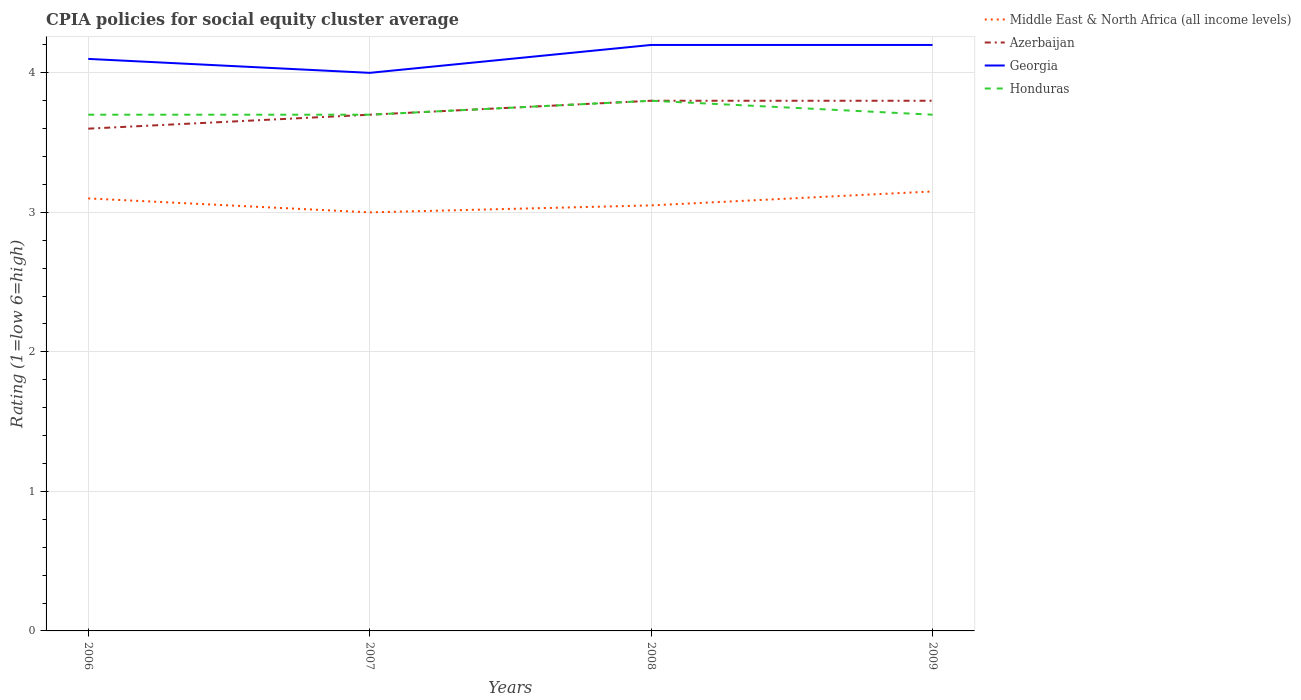Does the line corresponding to Honduras intersect with the line corresponding to Georgia?
Provide a short and direct response. No. Is the number of lines equal to the number of legend labels?
Keep it short and to the point. Yes. Across all years, what is the maximum CPIA rating in Azerbaijan?
Your answer should be compact. 3.6. What is the total CPIA rating in Middle East & North Africa (all income levels) in the graph?
Provide a short and direct response. -0.05. What is the difference between the highest and the second highest CPIA rating in Middle East & North Africa (all income levels)?
Offer a very short reply. 0.15. Is the CPIA rating in Azerbaijan strictly greater than the CPIA rating in Georgia over the years?
Keep it short and to the point. Yes. How many years are there in the graph?
Your answer should be compact. 4. What is the difference between two consecutive major ticks on the Y-axis?
Ensure brevity in your answer.  1. Are the values on the major ticks of Y-axis written in scientific E-notation?
Your answer should be very brief. No. Does the graph contain grids?
Make the answer very short. Yes. Where does the legend appear in the graph?
Make the answer very short. Top right. How many legend labels are there?
Your answer should be compact. 4. How are the legend labels stacked?
Give a very brief answer. Vertical. What is the title of the graph?
Give a very brief answer. CPIA policies for social equity cluster average. What is the Rating (1=low 6=high) in Azerbaijan in 2006?
Ensure brevity in your answer.  3.6. What is the Rating (1=low 6=high) in Georgia in 2007?
Give a very brief answer. 4. What is the Rating (1=low 6=high) in Honduras in 2007?
Your response must be concise. 3.7. What is the Rating (1=low 6=high) of Middle East & North Africa (all income levels) in 2008?
Provide a short and direct response. 3.05. What is the Rating (1=low 6=high) of Azerbaijan in 2008?
Make the answer very short. 3.8. What is the Rating (1=low 6=high) in Middle East & North Africa (all income levels) in 2009?
Your answer should be very brief. 3.15. What is the Rating (1=low 6=high) in Azerbaijan in 2009?
Offer a terse response. 3.8. What is the Rating (1=low 6=high) in Georgia in 2009?
Make the answer very short. 4.2. Across all years, what is the maximum Rating (1=low 6=high) of Middle East & North Africa (all income levels)?
Give a very brief answer. 3.15. Across all years, what is the maximum Rating (1=low 6=high) in Georgia?
Offer a very short reply. 4.2. Across all years, what is the minimum Rating (1=low 6=high) of Middle East & North Africa (all income levels)?
Provide a succinct answer. 3. Across all years, what is the minimum Rating (1=low 6=high) of Azerbaijan?
Offer a terse response. 3.6. Across all years, what is the minimum Rating (1=low 6=high) of Georgia?
Provide a succinct answer. 4. What is the total Rating (1=low 6=high) in Middle East & North Africa (all income levels) in the graph?
Make the answer very short. 12.3. What is the total Rating (1=low 6=high) in Honduras in the graph?
Provide a short and direct response. 14.9. What is the difference between the Rating (1=low 6=high) of Middle East & North Africa (all income levels) in 2006 and that in 2007?
Provide a succinct answer. 0.1. What is the difference between the Rating (1=low 6=high) in Georgia in 2006 and that in 2007?
Give a very brief answer. 0.1. What is the difference between the Rating (1=low 6=high) in Georgia in 2006 and that in 2008?
Your answer should be compact. -0.1. What is the difference between the Rating (1=low 6=high) of Azerbaijan in 2006 and that in 2009?
Give a very brief answer. -0.2. What is the difference between the Rating (1=low 6=high) in Georgia in 2006 and that in 2009?
Keep it short and to the point. -0.1. What is the difference between the Rating (1=low 6=high) of Middle East & North Africa (all income levels) in 2007 and that in 2008?
Provide a succinct answer. -0.05. What is the difference between the Rating (1=low 6=high) of Georgia in 2007 and that in 2008?
Keep it short and to the point. -0.2. What is the difference between the Rating (1=low 6=high) of Honduras in 2007 and that in 2008?
Offer a terse response. -0.1. What is the difference between the Rating (1=low 6=high) of Middle East & North Africa (all income levels) in 2007 and that in 2009?
Provide a short and direct response. -0.15. What is the difference between the Rating (1=low 6=high) in Azerbaijan in 2007 and that in 2009?
Your answer should be compact. -0.1. What is the difference between the Rating (1=low 6=high) in Middle East & North Africa (all income levels) in 2008 and that in 2009?
Offer a very short reply. -0.1. What is the difference between the Rating (1=low 6=high) of Georgia in 2008 and that in 2009?
Provide a short and direct response. 0. What is the difference between the Rating (1=low 6=high) of Middle East & North Africa (all income levels) in 2006 and the Rating (1=low 6=high) of Azerbaijan in 2007?
Give a very brief answer. -0.6. What is the difference between the Rating (1=low 6=high) in Azerbaijan in 2006 and the Rating (1=low 6=high) in Honduras in 2007?
Make the answer very short. -0.1. What is the difference between the Rating (1=low 6=high) in Georgia in 2006 and the Rating (1=low 6=high) in Honduras in 2007?
Provide a succinct answer. 0.4. What is the difference between the Rating (1=low 6=high) in Middle East & North Africa (all income levels) in 2006 and the Rating (1=low 6=high) in Georgia in 2008?
Offer a terse response. -1.1. What is the difference between the Rating (1=low 6=high) in Middle East & North Africa (all income levels) in 2006 and the Rating (1=low 6=high) in Honduras in 2008?
Provide a succinct answer. -0.7. What is the difference between the Rating (1=low 6=high) in Azerbaijan in 2006 and the Rating (1=low 6=high) in Georgia in 2008?
Provide a succinct answer. -0.6. What is the difference between the Rating (1=low 6=high) of Georgia in 2006 and the Rating (1=low 6=high) of Honduras in 2008?
Provide a succinct answer. 0.3. What is the difference between the Rating (1=low 6=high) in Middle East & North Africa (all income levels) in 2006 and the Rating (1=low 6=high) in Azerbaijan in 2009?
Ensure brevity in your answer.  -0.7. What is the difference between the Rating (1=low 6=high) in Middle East & North Africa (all income levels) in 2006 and the Rating (1=low 6=high) in Honduras in 2009?
Your answer should be compact. -0.6. What is the difference between the Rating (1=low 6=high) in Azerbaijan in 2006 and the Rating (1=low 6=high) in Georgia in 2009?
Your response must be concise. -0.6. What is the difference between the Rating (1=low 6=high) of Middle East & North Africa (all income levels) in 2007 and the Rating (1=low 6=high) of Georgia in 2008?
Your answer should be very brief. -1.2. What is the difference between the Rating (1=low 6=high) in Middle East & North Africa (all income levels) in 2007 and the Rating (1=low 6=high) in Honduras in 2008?
Provide a succinct answer. -0.8. What is the difference between the Rating (1=low 6=high) of Azerbaijan in 2007 and the Rating (1=low 6=high) of Honduras in 2008?
Provide a short and direct response. -0.1. What is the difference between the Rating (1=low 6=high) in Georgia in 2007 and the Rating (1=low 6=high) in Honduras in 2008?
Provide a succinct answer. 0.2. What is the difference between the Rating (1=low 6=high) of Middle East & North Africa (all income levels) in 2007 and the Rating (1=low 6=high) of Georgia in 2009?
Your response must be concise. -1.2. What is the difference between the Rating (1=low 6=high) in Middle East & North Africa (all income levels) in 2008 and the Rating (1=low 6=high) in Azerbaijan in 2009?
Provide a short and direct response. -0.75. What is the difference between the Rating (1=low 6=high) of Middle East & North Africa (all income levels) in 2008 and the Rating (1=low 6=high) of Georgia in 2009?
Keep it short and to the point. -1.15. What is the difference between the Rating (1=low 6=high) of Middle East & North Africa (all income levels) in 2008 and the Rating (1=low 6=high) of Honduras in 2009?
Offer a terse response. -0.65. What is the difference between the Rating (1=low 6=high) of Georgia in 2008 and the Rating (1=low 6=high) of Honduras in 2009?
Make the answer very short. 0.5. What is the average Rating (1=low 6=high) of Middle East & North Africa (all income levels) per year?
Give a very brief answer. 3.08. What is the average Rating (1=low 6=high) of Azerbaijan per year?
Your response must be concise. 3.73. What is the average Rating (1=low 6=high) in Georgia per year?
Give a very brief answer. 4.12. What is the average Rating (1=low 6=high) in Honduras per year?
Provide a succinct answer. 3.73. In the year 2006, what is the difference between the Rating (1=low 6=high) of Middle East & North Africa (all income levels) and Rating (1=low 6=high) of Azerbaijan?
Offer a very short reply. -0.5. In the year 2006, what is the difference between the Rating (1=low 6=high) of Azerbaijan and Rating (1=low 6=high) of Georgia?
Make the answer very short. -0.5. In the year 2006, what is the difference between the Rating (1=low 6=high) in Azerbaijan and Rating (1=low 6=high) in Honduras?
Keep it short and to the point. -0.1. In the year 2007, what is the difference between the Rating (1=low 6=high) of Middle East & North Africa (all income levels) and Rating (1=low 6=high) of Azerbaijan?
Give a very brief answer. -0.7. In the year 2007, what is the difference between the Rating (1=low 6=high) in Middle East & North Africa (all income levels) and Rating (1=low 6=high) in Georgia?
Your answer should be compact. -1. In the year 2007, what is the difference between the Rating (1=low 6=high) in Azerbaijan and Rating (1=low 6=high) in Honduras?
Offer a very short reply. 0. In the year 2008, what is the difference between the Rating (1=low 6=high) in Middle East & North Africa (all income levels) and Rating (1=low 6=high) in Azerbaijan?
Offer a terse response. -0.75. In the year 2008, what is the difference between the Rating (1=low 6=high) in Middle East & North Africa (all income levels) and Rating (1=low 6=high) in Georgia?
Your response must be concise. -1.15. In the year 2008, what is the difference between the Rating (1=low 6=high) in Middle East & North Africa (all income levels) and Rating (1=low 6=high) in Honduras?
Offer a very short reply. -0.75. In the year 2008, what is the difference between the Rating (1=low 6=high) of Azerbaijan and Rating (1=low 6=high) of Georgia?
Give a very brief answer. -0.4. In the year 2009, what is the difference between the Rating (1=low 6=high) of Middle East & North Africa (all income levels) and Rating (1=low 6=high) of Azerbaijan?
Your response must be concise. -0.65. In the year 2009, what is the difference between the Rating (1=low 6=high) of Middle East & North Africa (all income levels) and Rating (1=low 6=high) of Georgia?
Make the answer very short. -1.05. In the year 2009, what is the difference between the Rating (1=low 6=high) of Middle East & North Africa (all income levels) and Rating (1=low 6=high) of Honduras?
Provide a succinct answer. -0.55. In the year 2009, what is the difference between the Rating (1=low 6=high) in Azerbaijan and Rating (1=low 6=high) in Georgia?
Your answer should be very brief. -0.4. In the year 2009, what is the difference between the Rating (1=low 6=high) of Azerbaijan and Rating (1=low 6=high) of Honduras?
Offer a very short reply. 0.1. In the year 2009, what is the difference between the Rating (1=low 6=high) of Georgia and Rating (1=low 6=high) of Honduras?
Keep it short and to the point. 0.5. What is the ratio of the Rating (1=low 6=high) of Azerbaijan in 2006 to that in 2007?
Your response must be concise. 0.97. What is the ratio of the Rating (1=low 6=high) in Honduras in 2006 to that in 2007?
Provide a short and direct response. 1. What is the ratio of the Rating (1=low 6=high) in Middle East & North Africa (all income levels) in 2006 to that in 2008?
Your response must be concise. 1.02. What is the ratio of the Rating (1=low 6=high) of Azerbaijan in 2006 to that in 2008?
Offer a terse response. 0.95. What is the ratio of the Rating (1=low 6=high) in Georgia in 2006 to that in 2008?
Your response must be concise. 0.98. What is the ratio of the Rating (1=low 6=high) in Honduras in 2006 to that in 2008?
Make the answer very short. 0.97. What is the ratio of the Rating (1=low 6=high) in Middle East & North Africa (all income levels) in 2006 to that in 2009?
Your answer should be very brief. 0.98. What is the ratio of the Rating (1=low 6=high) of Azerbaijan in 2006 to that in 2009?
Provide a short and direct response. 0.95. What is the ratio of the Rating (1=low 6=high) of Georgia in 2006 to that in 2009?
Ensure brevity in your answer.  0.98. What is the ratio of the Rating (1=low 6=high) of Middle East & North Africa (all income levels) in 2007 to that in 2008?
Give a very brief answer. 0.98. What is the ratio of the Rating (1=low 6=high) of Azerbaijan in 2007 to that in 2008?
Ensure brevity in your answer.  0.97. What is the ratio of the Rating (1=low 6=high) in Georgia in 2007 to that in 2008?
Provide a short and direct response. 0.95. What is the ratio of the Rating (1=low 6=high) of Honduras in 2007 to that in 2008?
Offer a terse response. 0.97. What is the ratio of the Rating (1=low 6=high) of Middle East & North Africa (all income levels) in 2007 to that in 2009?
Ensure brevity in your answer.  0.95. What is the ratio of the Rating (1=low 6=high) of Azerbaijan in 2007 to that in 2009?
Your answer should be compact. 0.97. What is the ratio of the Rating (1=low 6=high) of Georgia in 2007 to that in 2009?
Offer a terse response. 0.95. What is the ratio of the Rating (1=low 6=high) in Middle East & North Africa (all income levels) in 2008 to that in 2009?
Your answer should be very brief. 0.97. What is the ratio of the Rating (1=low 6=high) of Azerbaijan in 2008 to that in 2009?
Your answer should be very brief. 1. What is the difference between the highest and the second highest Rating (1=low 6=high) of Azerbaijan?
Your response must be concise. 0. What is the difference between the highest and the lowest Rating (1=low 6=high) in Azerbaijan?
Give a very brief answer. 0.2. What is the difference between the highest and the lowest Rating (1=low 6=high) of Georgia?
Your answer should be compact. 0.2. What is the difference between the highest and the lowest Rating (1=low 6=high) in Honduras?
Your response must be concise. 0.1. 